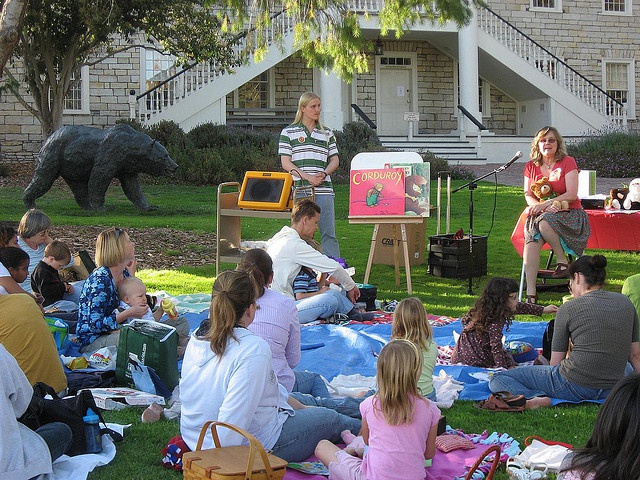Describe the objects in this image and their specific colors. I can see people in black, darkgray, lightblue, lavender, and gray tones, people in black, gray, darkblue, and navy tones, people in black, violet, and gray tones, bear in black, gray, and darkblue tones, and people in black, gray, maroon, and lightpink tones in this image. 